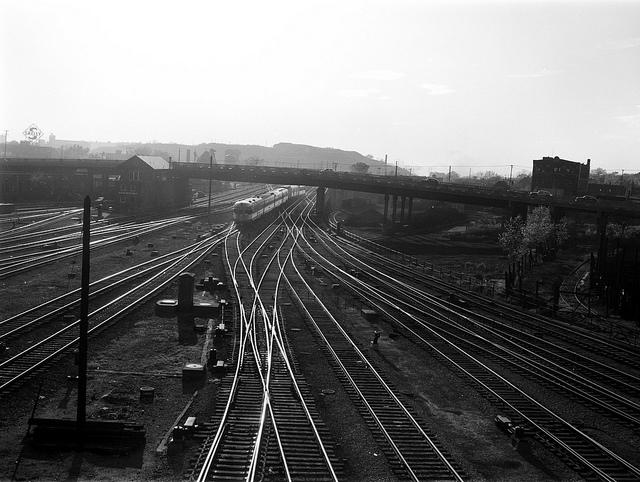Are these train tracks made out of metal?
Keep it brief. Yes. Is this black and white?
Quick response, please. Yes. Is there a train visible?
Concise answer only. Yes. 